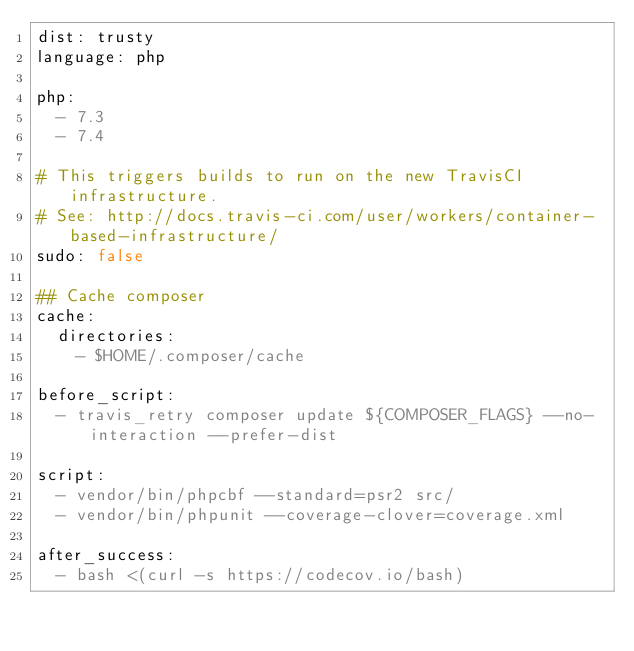Convert code to text. <code><loc_0><loc_0><loc_500><loc_500><_YAML_>dist: trusty
language: php

php:
  - 7.3
  - 7.4

# This triggers builds to run on the new TravisCI infrastructure.
# See: http://docs.travis-ci.com/user/workers/container-based-infrastructure/
sudo: false

## Cache composer
cache:
  directories:
    - $HOME/.composer/cache

before_script:
  - travis_retry composer update ${COMPOSER_FLAGS} --no-interaction --prefer-dist

script:
  - vendor/bin/phpcbf --standard=psr2 src/
  - vendor/bin/phpunit --coverage-clover=coverage.xml

after_success:
  - bash <(curl -s https://codecov.io/bash)</code> 